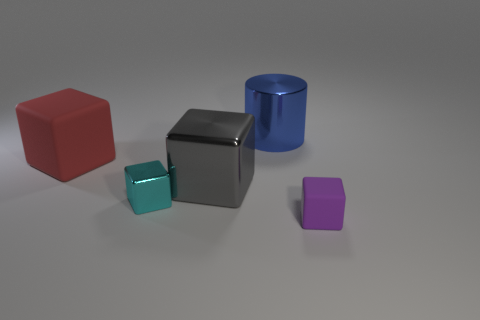Subtract all big gray cubes. How many cubes are left? 3 Subtract all gray blocks. How many blocks are left? 3 Add 3 cylinders. How many objects exist? 8 Subtract 3 blocks. How many blocks are left? 1 Subtract all cubes. How many objects are left? 1 Subtract all blue cylinders. How many blue cubes are left? 0 Subtract all blue cubes. Subtract all purple cubes. How many objects are left? 4 Add 4 large cylinders. How many large cylinders are left? 5 Add 5 red things. How many red things exist? 6 Subtract 0 yellow balls. How many objects are left? 5 